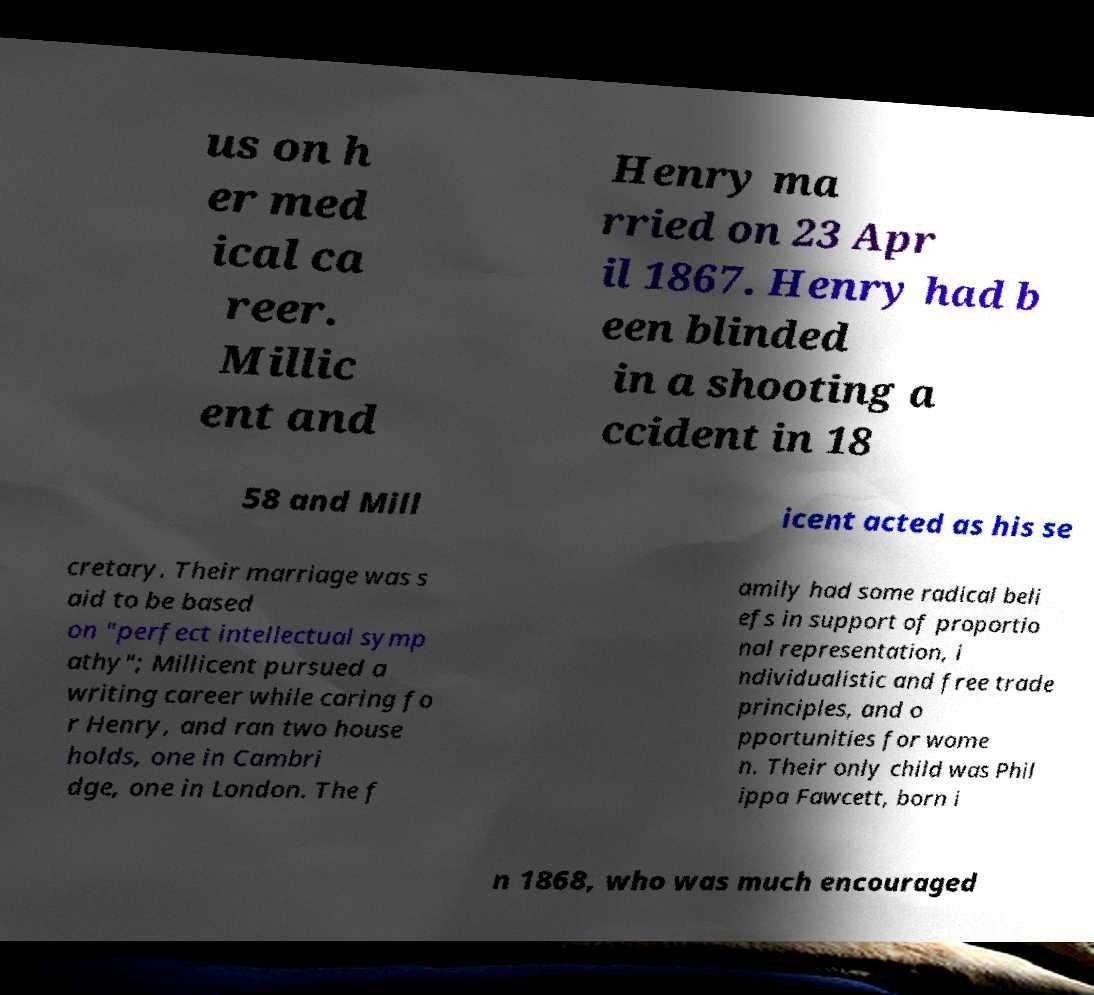For documentation purposes, I need the text within this image transcribed. Could you provide that? us on h er med ical ca reer. Millic ent and Henry ma rried on 23 Apr il 1867. Henry had b een blinded in a shooting a ccident in 18 58 and Mill icent acted as his se cretary. Their marriage was s aid to be based on "perfect intellectual symp athy"; Millicent pursued a writing career while caring fo r Henry, and ran two house holds, one in Cambri dge, one in London. The f amily had some radical beli efs in support of proportio nal representation, i ndividualistic and free trade principles, and o pportunities for wome n. Their only child was Phil ippa Fawcett, born i n 1868, who was much encouraged 